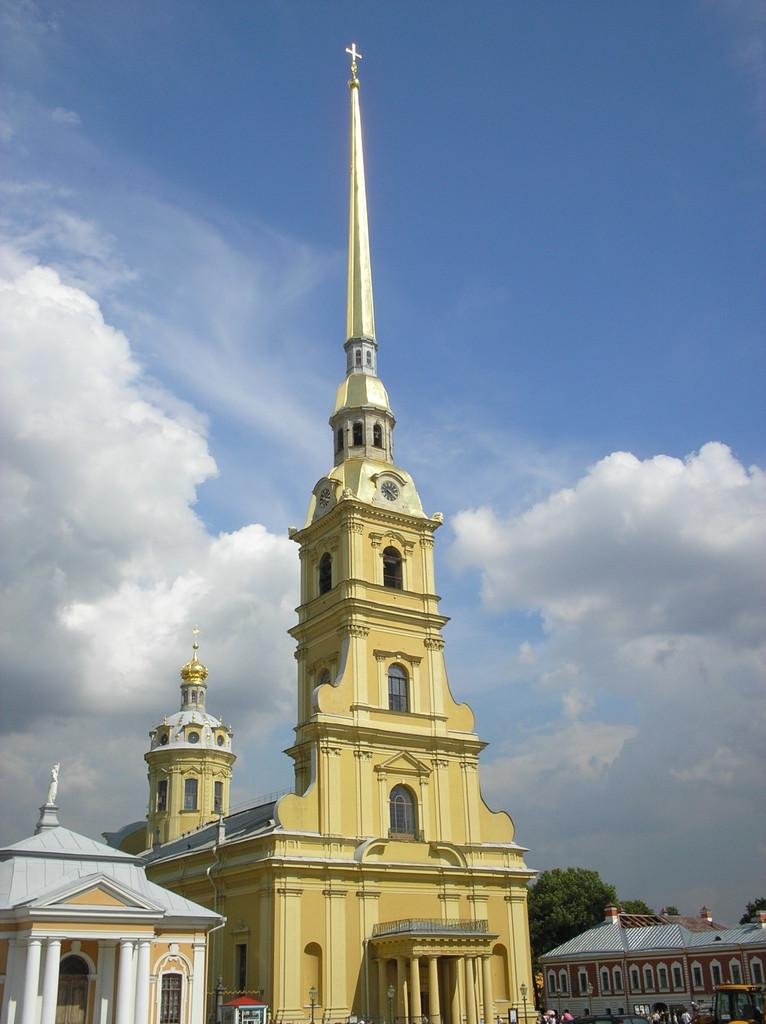What type of structures are located in the foreground of the image? There are buildings in the foreground of the image. Can you identify any specific building in the image? Yes, there appears to be a church in the middle of the buildings. What can be seen in the background of the image? The sky is visible in the background of the image. What is the condition of the sky in the image? Clouds are present in the sky. What type of scent can be detected coming from the church in the image? There is no indication of any scent in the image, as it only shows buildings and a church. --- Facts: 1. There is a person holding a camera in the image. 2. The person is standing on a bridge. 3. The bridge is over a river. 4. There are trees on both sides of the river. 5. The sky is visible in the background of the image. Absurd Topics: dance, piano, ocean Conversation: What is the person in the image holding? The person in the image is holding a camera. Where is the person standing in the image? The person is standing on a bridge. What is the bridge positioned over in the image? The bridge is over a river. What type of vegetation can be seen on both sides of the river? There are trees on both sides of the river. What is visible in the background of the image? The sky is visible in the background of the image. Reasoning: Let's think step by step in order to produce the conversation. We start by identifying the main subject in the image, which is the person holding a camera. Then, we expand the conversation to include other details about the person's location and the surrounding environment, such as the bridge, river, trees, and sky. Each question is designed to elicit a specific detail about the image that is known from the provided facts. Absurd Question/Answer: Can you hear the person playing the piano on the bridge in the image? There is no piano or indication of any sound in the image, as it only shows a person holding a camera on a bridge over a river. 